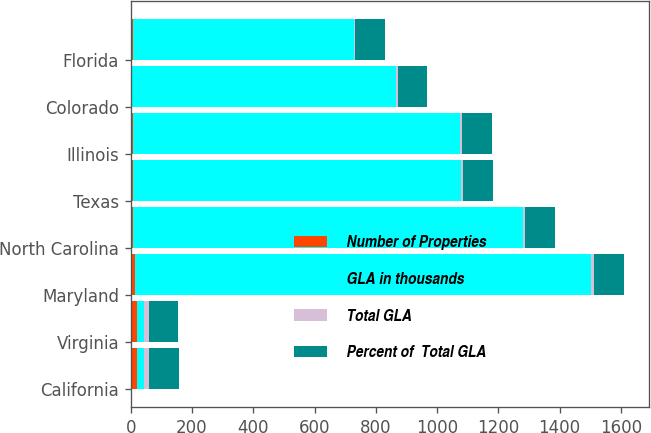Convert chart. <chart><loc_0><loc_0><loc_500><loc_500><stacked_bar_chart><ecel><fcel>California<fcel>Virginia<fcel>Maryland<fcel>North Carolina<fcel>Texas<fcel>Illinois<fcel>Colorado<fcel>Florida<nl><fcel>Number of Properties<fcel>21<fcel>21<fcel>13<fcel>8<fcel>8<fcel>8<fcel>5<fcel>9<nl><fcel>GLA in thousands<fcel>21<fcel>21<fcel>1490<fcel>1272<fcel>1070<fcel>1067<fcel>862<fcel>720<nl><fcel>Total GLA<fcel>17.9<fcel>17.3<fcel>9.6<fcel>8.2<fcel>6.9<fcel>6.9<fcel>5.6<fcel>4.6<nl><fcel>Percent of  Total GLA<fcel>96.9<fcel>96.6<fcel>97<fcel>97.3<fcel>98.6<fcel>97.3<fcel>95.1<fcel>95.3<nl></chart> 